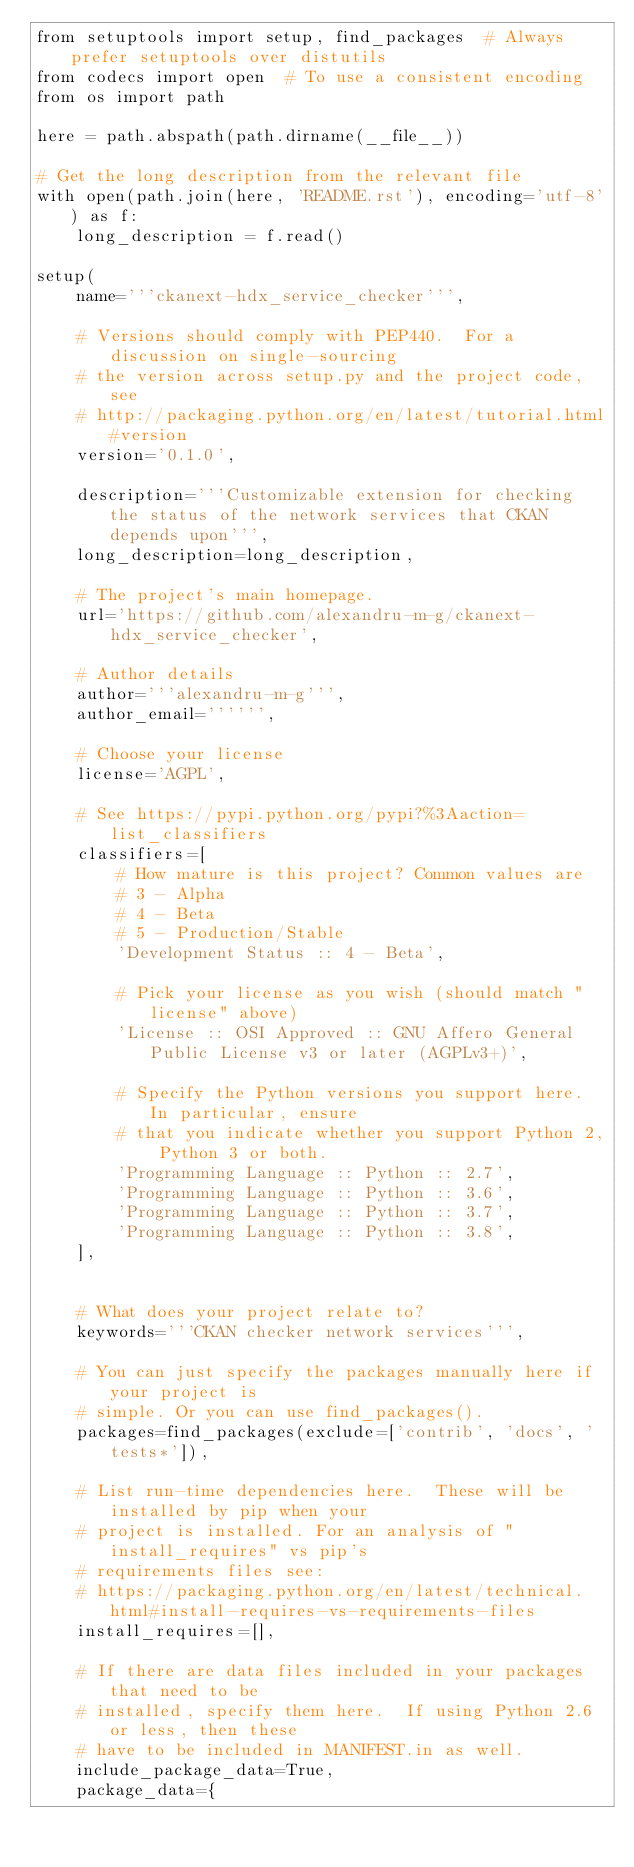Convert code to text. <code><loc_0><loc_0><loc_500><loc_500><_Python_>from setuptools import setup, find_packages  # Always prefer setuptools over distutils
from codecs import open  # To use a consistent encoding
from os import path

here = path.abspath(path.dirname(__file__))

# Get the long description from the relevant file
with open(path.join(here, 'README.rst'), encoding='utf-8') as f:
    long_description = f.read()

setup(
    name='''ckanext-hdx_service_checker''',

    # Versions should comply with PEP440.  For a discussion on single-sourcing
    # the version across setup.py and the project code, see
    # http://packaging.python.org/en/latest/tutorial.html#version
    version='0.1.0',

    description='''Customizable extension for checking the status of the network services that CKAN depends upon''',
    long_description=long_description,

    # The project's main homepage.
    url='https://github.com/alexandru-m-g/ckanext-hdx_service_checker',

    # Author details
    author='''alexandru-m-g''',
    author_email='''''',

    # Choose your license
    license='AGPL',

    # See https://pypi.python.org/pypi?%3Aaction=list_classifiers
    classifiers=[
        # How mature is this project? Common values are
        # 3 - Alpha
        # 4 - Beta
        # 5 - Production/Stable
        'Development Status :: 4 - Beta',

        # Pick your license as you wish (should match "license" above)
        'License :: OSI Approved :: GNU Affero General Public License v3 or later (AGPLv3+)',

        # Specify the Python versions you support here. In particular, ensure
        # that you indicate whether you support Python 2, Python 3 or both.
        'Programming Language :: Python :: 2.7',
        'Programming Language :: Python :: 3.6',
        'Programming Language :: Python :: 3.7',
        'Programming Language :: Python :: 3.8',
    ],


    # What does your project relate to?
    keywords='''CKAN checker network services''',

    # You can just specify the packages manually here if your project is
    # simple. Or you can use find_packages().
    packages=find_packages(exclude=['contrib', 'docs', 'tests*']),

    # List run-time dependencies here.  These will be installed by pip when your
    # project is installed. For an analysis of "install_requires" vs pip's
    # requirements files see:
    # https://packaging.python.org/en/latest/technical.html#install-requires-vs-requirements-files
    install_requires=[],

    # If there are data files included in your packages that need to be
    # installed, specify them here.  If using Python 2.6 or less, then these
    # have to be included in MANIFEST.in as well.
    include_package_data=True,
    package_data={</code> 